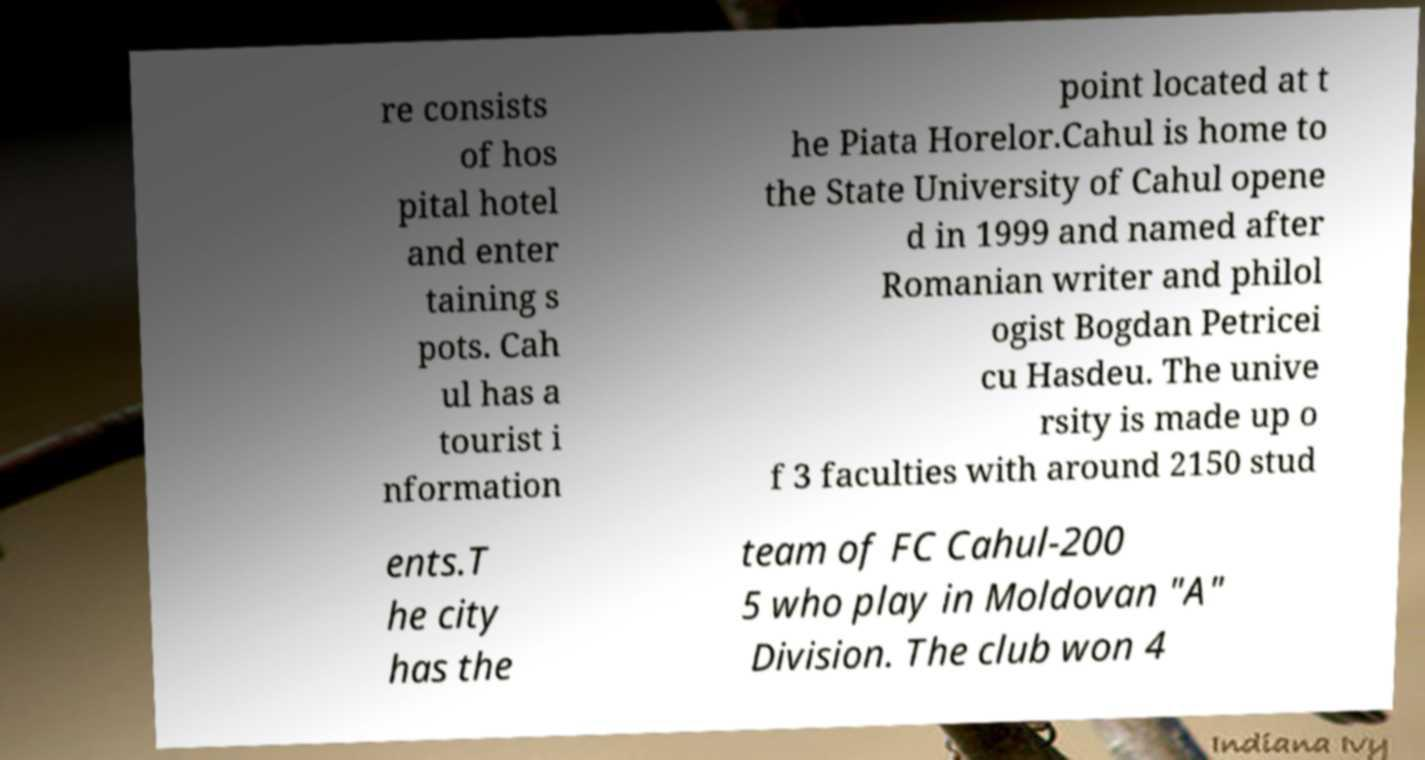Please read and relay the text visible in this image. What does it say? re consists of hos pital hotel and enter taining s pots. Cah ul has a tourist i nformation point located at t he Piata Horelor.Cahul is home to the State University of Cahul opene d in 1999 and named after Romanian writer and philol ogist Bogdan Petricei cu Hasdeu. The unive rsity is made up o f 3 faculties with around 2150 stud ents.T he city has the team of FC Cahul-200 5 who play in Moldovan "A" Division. The club won 4 